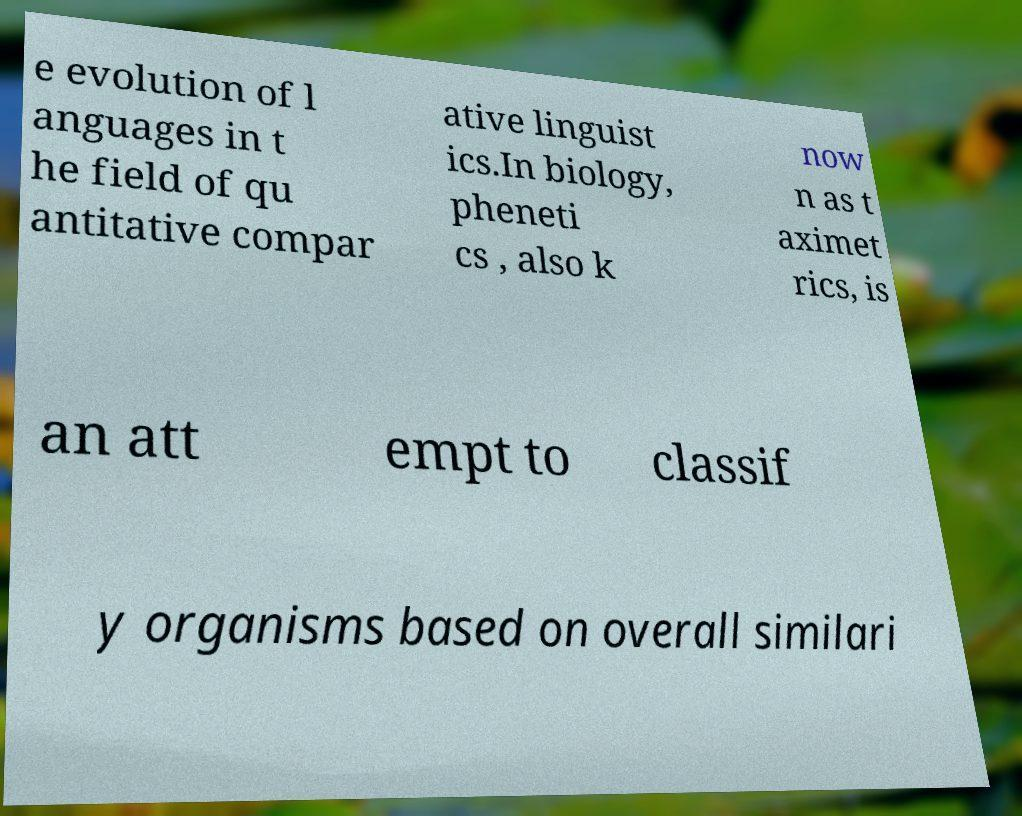Can you accurately transcribe the text from the provided image for me? e evolution of l anguages in t he field of qu antitative compar ative linguist ics.In biology, pheneti cs , also k now n as t aximet rics, is an att empt to classif y organisms based on overall similari 